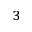<formula> <loc_0><loc_0><loc_500><loc_500>{ ^ { 3 } }</formula> 